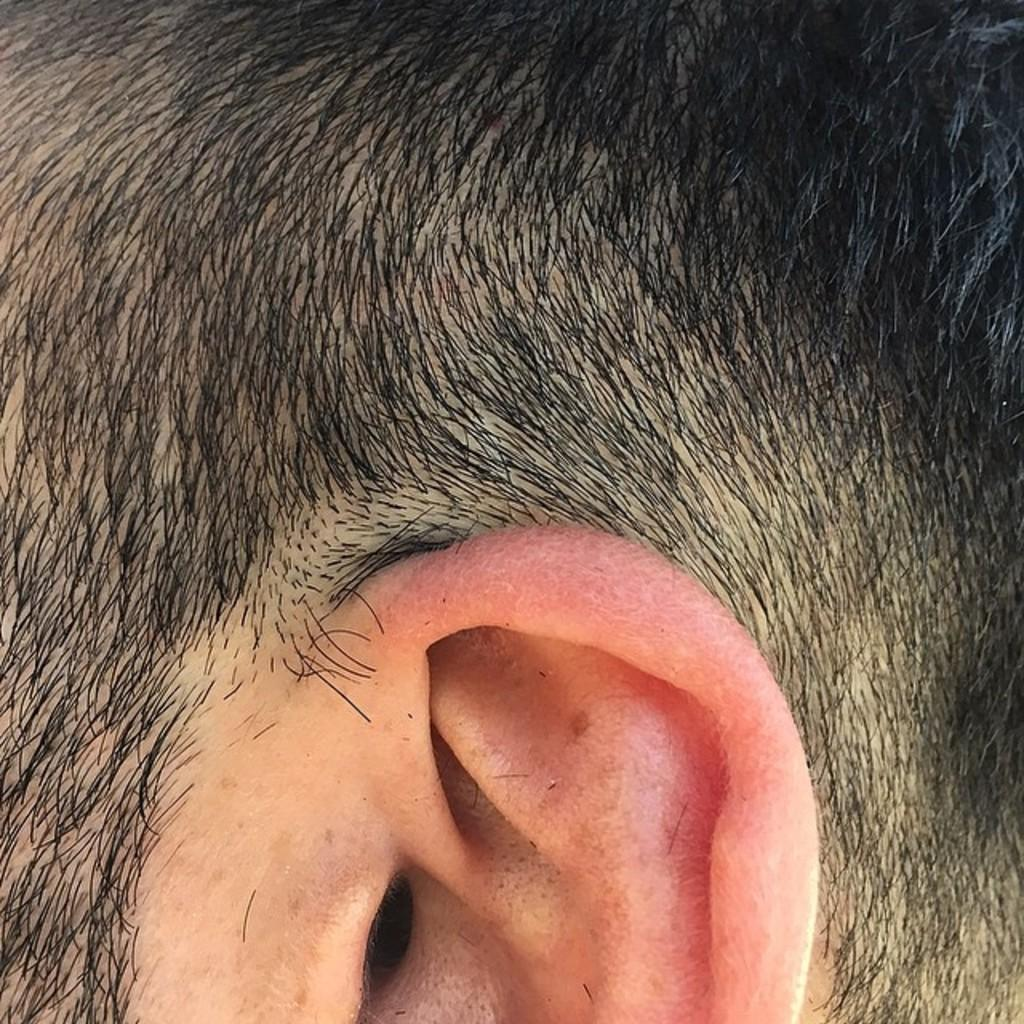What body part can be seen in the image? There is an ear visible in the image. What else can be seen in the image besides the ear? There is hair visible in the image. How many passengers are in the lift in the image? There is no lift or passengers present in the image; it only features an ear and hair. 